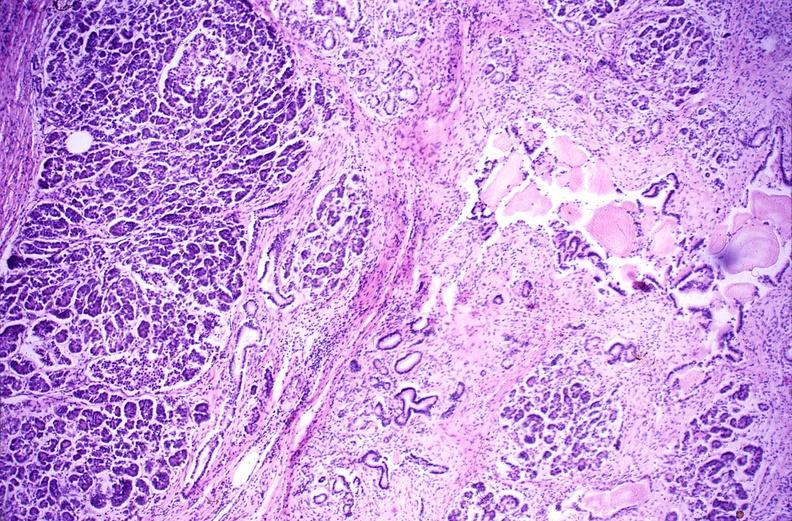what does this image show?
Answer the question using a single word or phrase. Chronic pancreatitis 